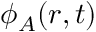<formula> <loc_0><loc_0><loc_500><loc_500>\phi _ { A } ( \boldsymbol r , t )</formula> 